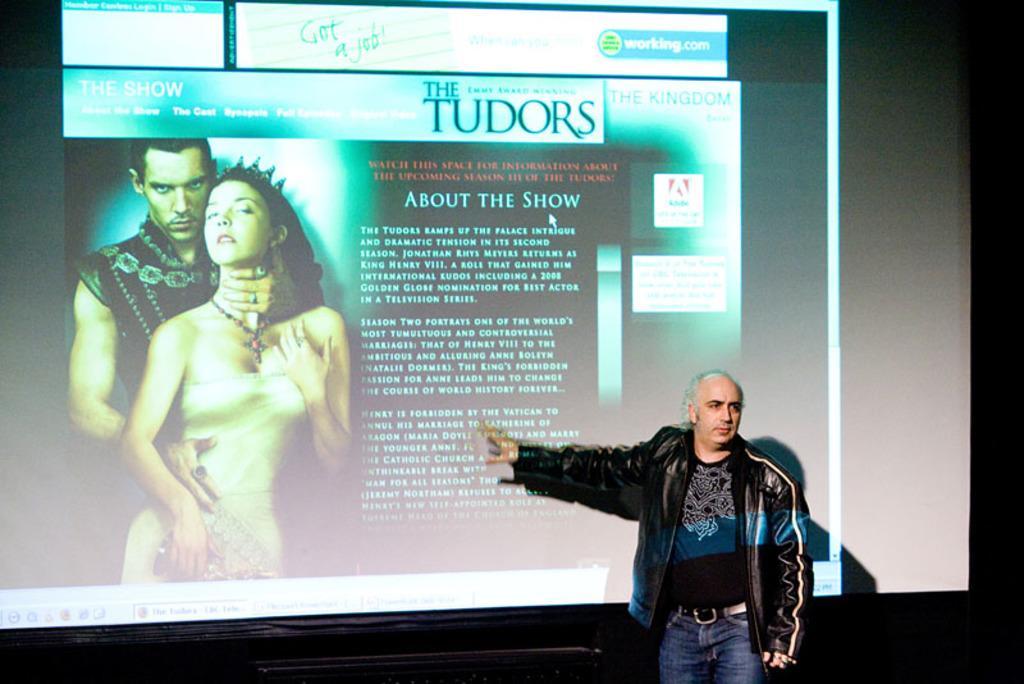Can you describe this image briefly? At the bottom of the image a person is standing. Behind him we can see a screen. In the screen we can see some text and two persons are standing. 